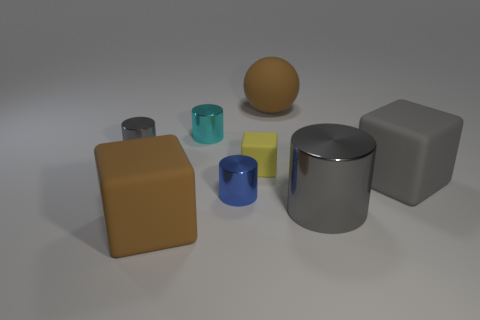What is the shape of the big matte thing that is the same color as the large metal thing?
Your answer should be compact. Cube. The thing that is the same color as the large rubber sphere is what size?
Your answer should be compact. Large. How many gray things are to the left of the big brown thing behind the big cube to the left of the small yellow block?
Offer a very short reply. 1. The rubber thing in front of the big gray metallic cylinder is what color?
Offer a very short reply. Brown. Does the big matte block that is on the right side of the big cylinder have the same color as the matte ball?
Your response must be concise. No. There is a blue shiny thing that is the same shape as the cyan shiny thing; what size is it?
Ensure brevity in your answer.  Small. Is there any other thing that has the same size as the blue shiny thing?
Provide a short and direct response. Yes. What material is the gray thing that is to the left of the large block left of the rubber block that is to the right of the large gray cylinder made of?
Provide a short and direct response. Metal. Are there more brown matte balls that are to the right of the large shiny cylinder than big metal things left of the blue shiny cylinder?
Make the answer very short. No. Is the size of the gray rubber object the same as the blue shiny cylinder?
Offer a terse response. No. 